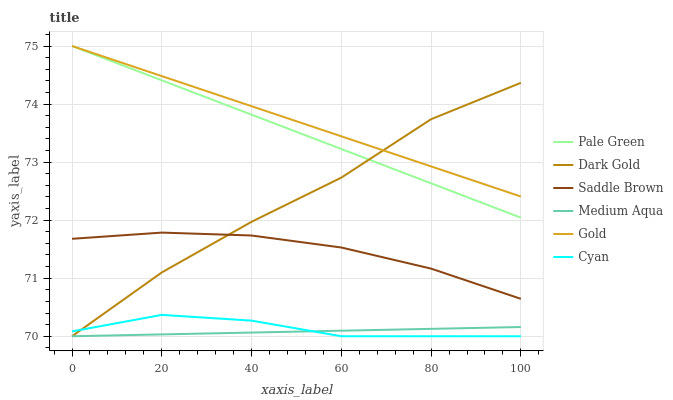Does Medium Aqua have the minimum area under the curve?
Answer yes or no. Yes. Does Gold have the maximum area under the curve?
Answer yes or no. Yes. Does Dark Gold have the minimum area under the curve?
Answer yes or no. No. Does Dark Gold have the maximum area under the curve?
Answer yes or no. No. Is Gold the smoothest?
Answer yes or no. Yes. Is Dark Gold the roughest?
Answer yes or no. Yes. Is Dark Gold the smoothest?
Answer yes or no. No. Is Pale Green the roughest?
Answer yes or no. No. Does Dark Gold have the lowest value?
Answer yes or no. Yes. Does Pale Green have the lowest value?
Answer yes or no. No. Does Pale Green have the highest value?
Answer yes or no. Yes. Does Dark Gold have the highest value?
Answer yes or no. No. Is Saddle Brown less than Pale Green?
Answer yes or no. Yes. Is Saddle Brown greater than Cyan?
Answer yes or no. Yes. Does Medium Aqua intersect Cyan?
Answer yes or no. Yes. Is Medium Aqua less than Cyan?
Answer yes or no. No. Is Medium Aqua greater than Cyan?
Answer yes or no. No. Does Saddle Brown intersect Pale Green?
Answer yes or no. No. 